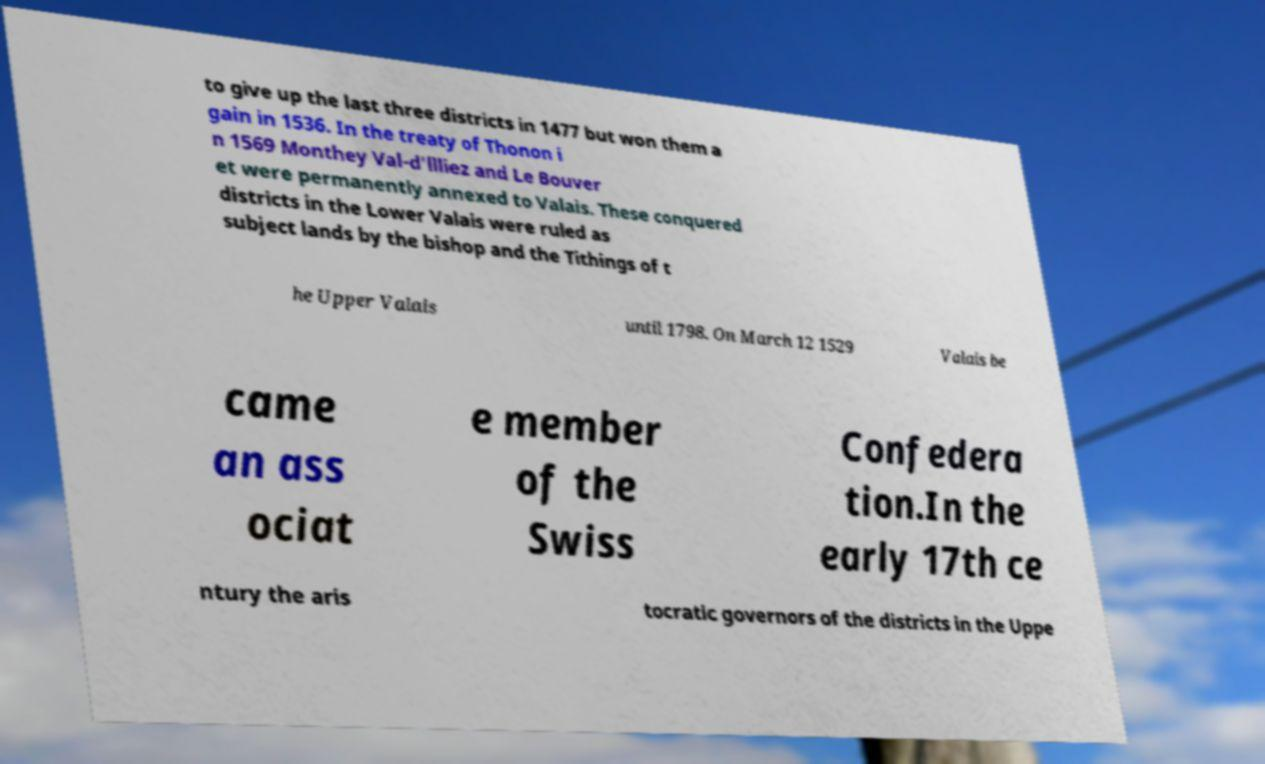Can you accurately transcribe the text from the provided image for me? to give up the last three districts in 1477 but won them a gain in 1536. In the treaty of Thonon i n 1569 Monthey Val-d'llliez and Le Bouver et were permanently annexed to Valais. These conquered districts in the Lower Valais were ruled as subject lands by the bishop and the Tithings of t he Upper Valais until 1798. On March 12 1529 Valais be came an ass ociat e member of the Swiss Confedera tion.In the early 17th ce ntury the aris tocratic governors of the districts in the Uppe 